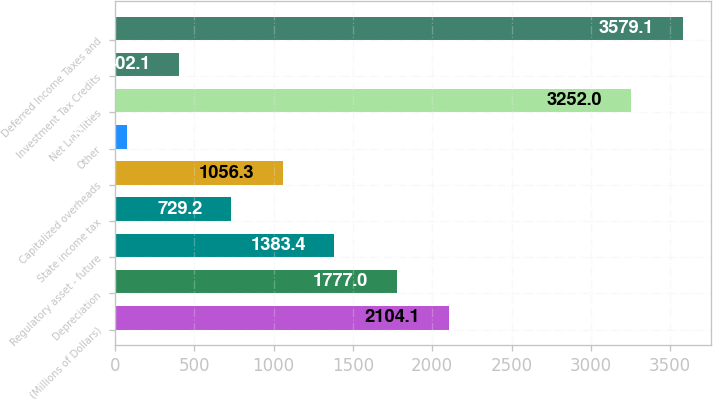Convert chart. <chart><loc_0><loc_0><loc_500><loc_500><bar_chart><fcel>(Millions of Dollars)<fcel>Depreciation<fcel>Regulatory asset - future<fcel>State income tax<fcel>Capitalized overheads<fcel>Other<fcel>Net Liabilities<fcel>Investment Tax Credits<fcel>Deferred Income Taxes and<nl><fcel>2104.1<fcel>1777<fcel>1383.4<fcel>729.2<fcel>1056.3<fcel>75<fcel>3252<fcel>402.1<fcel>3579.1<nl></chart> 